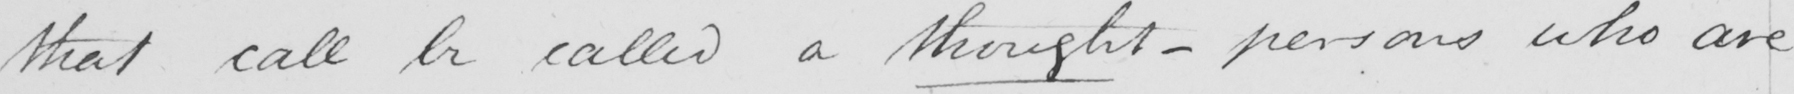What does this handwritten line say? that call be called a thought  _  persons who are 